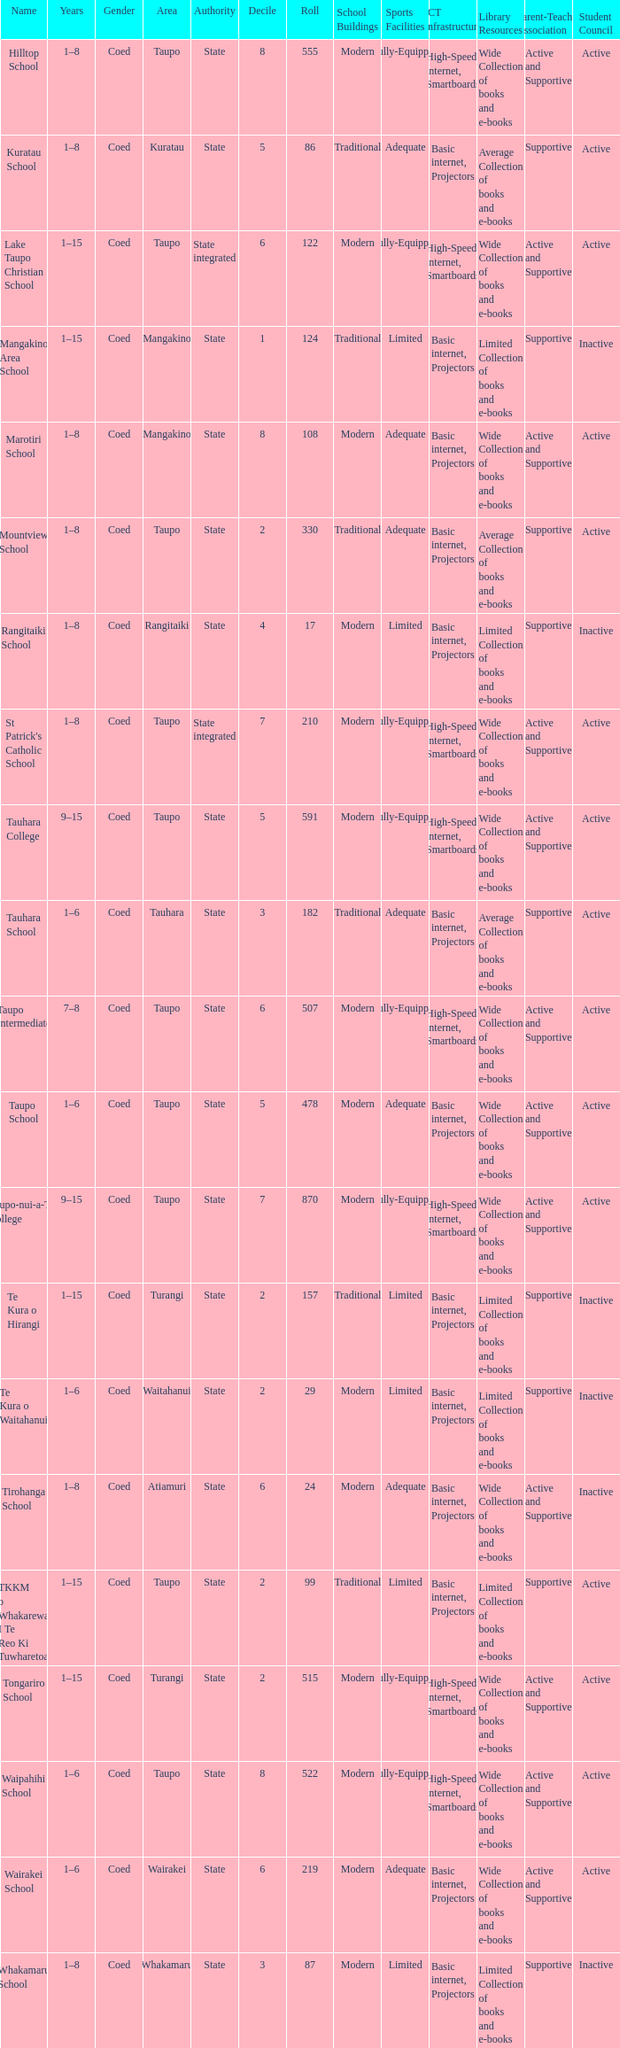Where is the school with state authority that has a roll of more than 157 students? Taupo, Taupo, Taupo, Tauhara, Taupo, Taupo, Taupo, Turangi, Taupo, Wairakei. 